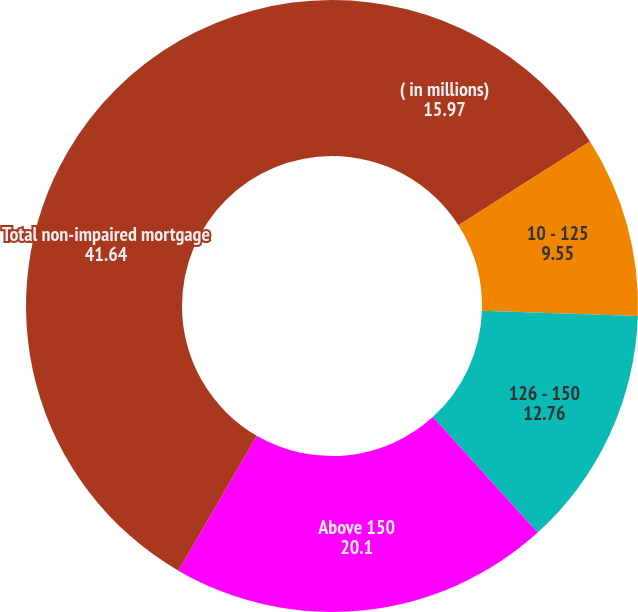Convert chart to OTSL. <chart><loc_0><loc_0><loc_500><loc_500><pie_chart><fcel>( in millions)<fcel>10 - 125<fcel>126 - 150<fcel>Above 150<fcel>Total non-impaired mortgage<nl><fcel>15.97%<fcel>9.55%<fcel>12.76%<fcel>20.1%<fcel>41.64%<nl></chart> 